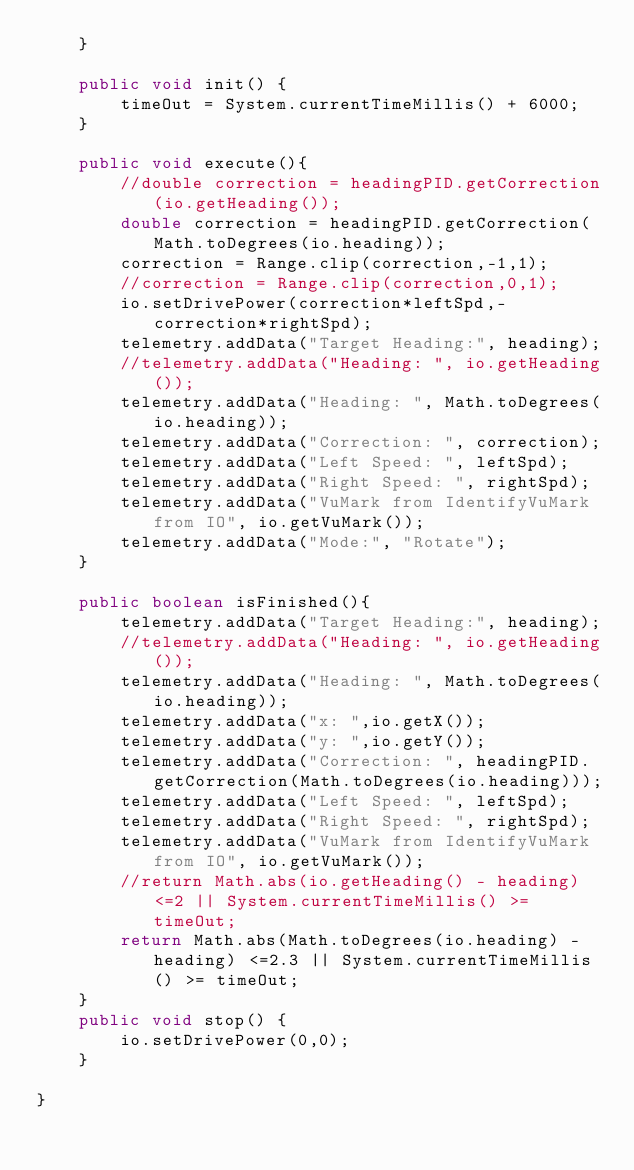<code> <loc_0><loc_0><loc_500><loc_500><_Java_>    }

    public void init() {
        timeOut = System.currentTimeMillis() + 6000;
    }

    public void execute(){
        //double correction = headingPID.getCorrection(io.getHeading());
        double correction = headingPID.getCorrection(Math.toDegrees(io.heading));
        correction = Range.clip(correction,-1,1);
        //correction = Range.clip(correction,0,1);
        io.setDrivePower(correction*leftSpd,-correction*rightSpd);
        telemetry.addData("Target Heading:", heading);
        //telemetry.addData("Heading: ", io.getHeading());
        telemetry.addData("Heading: ", Math.toDegrees(io.heading));
        telemetry.addData("Correction: ", correction);
        telemetry.addData("Left Speed: ", leftSpd);
        telemetry.addData("Right Speed: ", rightSpd);
        telemetry.addData("VuMark from IdentifyVuMark from IO", io.getVuMark());
        telemetry.addData("Mode:", "Rotate");
    }

    public boolean isFinished(){
        telemetry.addData("Target Heading:", heading);
        //telemetry.addData("Heading: ", io.getHeading());
        telemetry.addData("Heading: ", Math.toDegrees(io.heading));
        telemetry.addData("x: ",io.getX());
        telemetry.addData("y: ",io.getY());
        telemetry.addData("Correction: ", headingPID.getCorrection(Math.toDegrees(io.heading)));
        telemetry.addData("Left Speed: ", leftSpd);
        telemetry.addData("Right Speed: ", rightSpd);
        telemetry.addData("VuMark from IdentifyVuMark from IO", io.getVuMark());
        //return Math.abs(io.getHeading() - heading) <=2 || System.currentTimeMillis() >= timeOut;
        return Math.abs(Math.toDegrees(io.heading) - heading) <=2.3 || System.currentTimeMillis() >= timeOut;
    }
    public void stop() {
        io.setDrivePower(0,0);
    }

}
</code> 